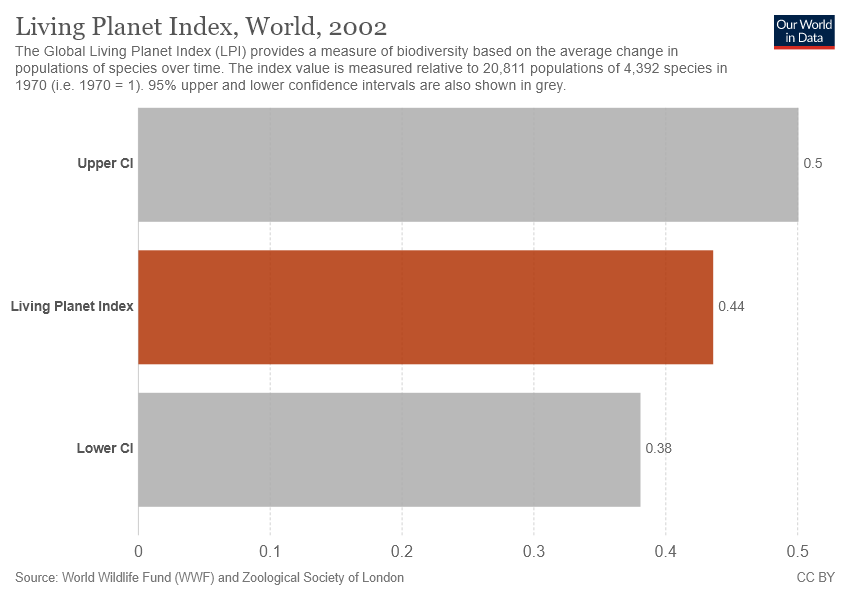Mention a couple of crucial points in this snapshot. The sum of both grey color bars is 0.88. There are three bars in the graph. 